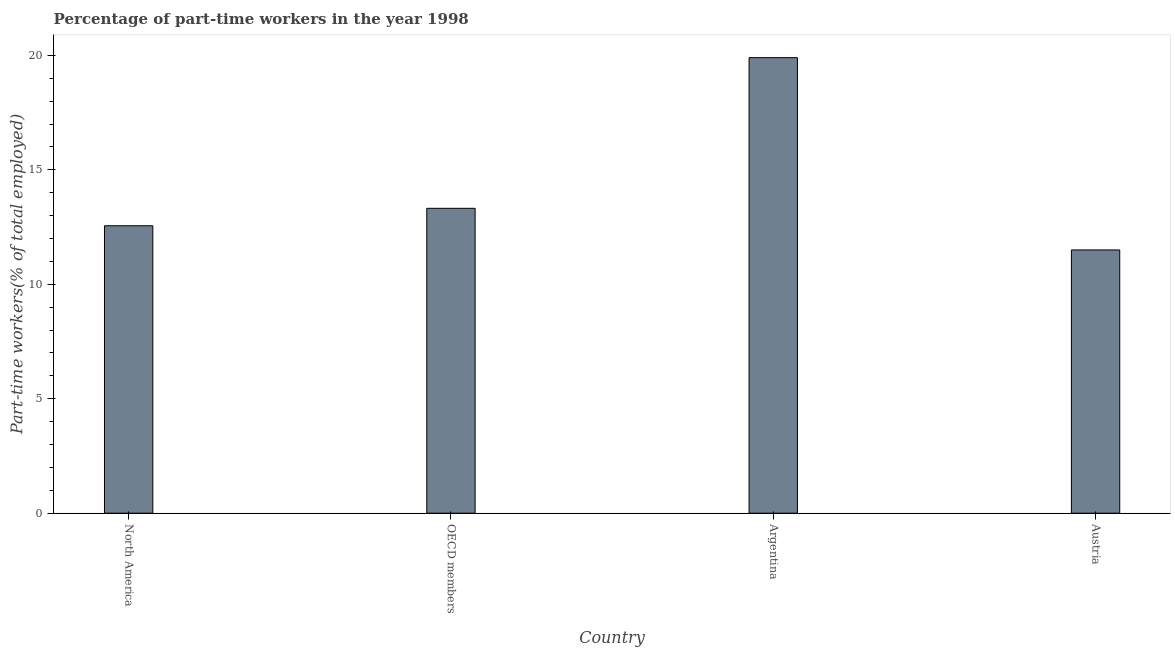What is the title of the graph?
Provide a short and direct response. Percentage of part-time workers in the year 1998. What is the label or title of the Y-axis?
Your response must be concise. Part-time workers(% of total employed). What is the percentage of part-time workers in Austria?
Offer a very short reply. 11.5. Across all countries, what is the maximum percentage of part-time workers?
Keep it short and to the point. 19.9. In which country was the percentage of part-time workers maximum?
Provide a short and direct response. Argentina. In which country was the percentage of part-time workers minimum?
Offer a very short reply. Austria. What is the sum of the percentage of part-time workers?
Your answer should be very brief. 57.28. What is the difference between the percentage of part-time workers in Austria and OECD members?
Your response must be concise. -1.82. What is the average percentage of part-time workers per country?
Ensure brevity in your answer.  14.32. What is the median percentage of part-time workers?
Offer a terse response. 12.94. What is the ratio of the percentage of part-time workers in Austria to that in OECD members?
Offer a very short reply. 0.86. Is the percentage of part-time workers in Austria less than that in North America?
Offer a terse response. Yes. What is the difference between the highest and the second highest percentage of part-time workers?
Provide a succinct answer. 6.58. What is the difference between the highest and the lowest percentage of part-time workers?
Your answer should be compact. 8.4. In how many countries, is the percentage of part-time workers greater than the average percentage of part-time workers taken over all countries?
Give a very brief answer. 1. How many bars are there?
Offer a very short reply. 4. How many countries are there in the graph?
Your response must be concise. 4. Are the values on the major ticks of Y-axis written in scientific E-notation?
Offer a terse response. No. What is the Part-time workers(% of total employed) in North America?
Give a very brief answer. 12.56. What is the Part-time workers(% of total employed) in OECD members?
Offer a very short reply. 13.32. What is the Part-time workers(% of total employed) in Argentina?
Make the answer very short. 19.9. What is the Part-time workers(% of total employed) of Austria?
Make the answer very short. 11.5. What is the difference between the Part-time workers(% of total employed) in North America and OECD members?
Ensure brevity in your answer.  -0.76. What is the difference between the Part-time workers(% of total employed) in North America and Argentina?
Provide a succinct answer. -7.34. What is the difference between the Part-time workers(% of total employed) in North America and Austria?
Ensure brevity in your answer.  1.06. What is the difference between the Part-time workers(% of total employed) in OECD members and Argentina?
Your answer should be very brief. -6.58. What is the difference between the Part-time workers(% of total employed) in OECD members and Austria?
Provide a succinct answer. 1.82. What is the difference between the Part-time workers(% of total employed) in Argentina and Austria?
Offer a very short reply. 8.4. What is the ratio of the Part-time workers(% of total employed) in North America to that in OECD members?
Provide a succinct answer. 0.94. What is the ratio of the Part-time workers(% of total employed) in North America to that in Argentina?
Your response must be concise. 0.63. What is the ratio of the Part-time workers(% of total employed) in North America to that in Austria?
Offer a terse response. 1.09. What is the ratio of the Part-time workers(% of total employed) in OECD members to that in Argentina?
Your answer should be compact. 0.67. What is the ratio of the Part-time workers(% of total employed) in OECD members to that in Austria?
Provide a short and direct response. 1.16. What is the ratio of the Part-time workers(% of total employed) in Argentina to that in Austria?
Make the answer very short. 1.73. 